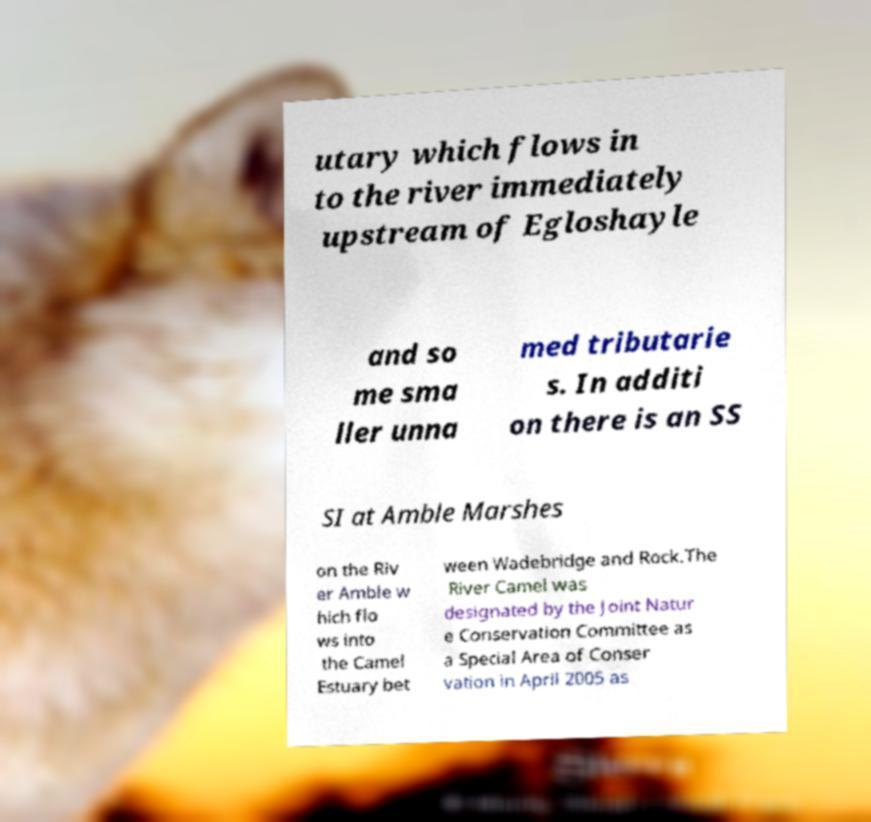Can you read and provide the text displayed in the image?This photo seems to have some interesting text. Can you extract and type it out for me? utary which flows in to the river immediately upstream of Egloshayle and so me sma ller unna med tributarie s. In additi on there is an SS SI at Amble Marshes on the Riv er Amble w hich flo ws into the Camel Estuary bet ween Wadebridge and Rock.The River Camel was designated by the Joint Natur e Conservation Committee as a Special Area of Conser vation in April 2005 as 